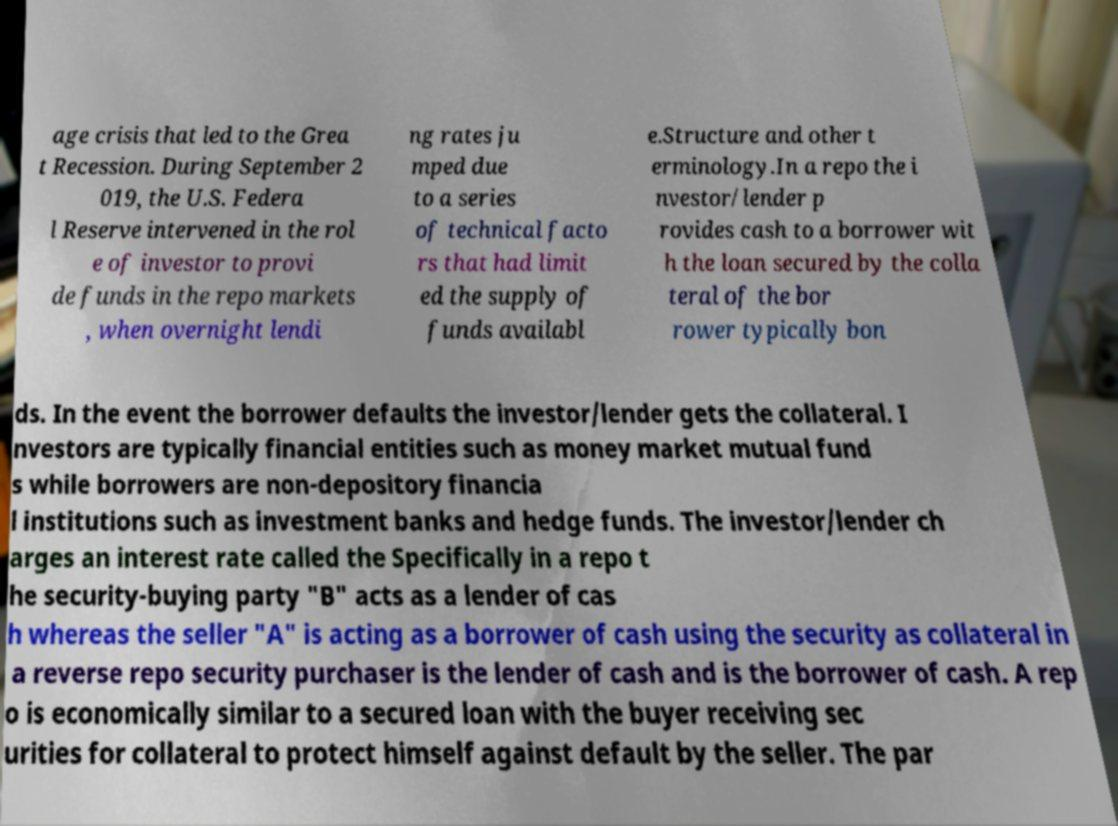Please identify and transcribe the text found in this image. age crisis that led to the Grea t Recession. During September 2 019, the U.S. Federa l Reserve intervened in the rol e of investor to provi de funds in the repo markets , when overnight lendi ng rates ju mped due to a series of technical facto rs that had limit ed the supply of funds availabl e.Structure and other t erminology.In a repo the i nvestor/lender p rovides cash to a borrower wit h the loan secured by the colla teral of the bor rower typically bon ds. In the event the borrower defaults the investor/lender gets the collateral. I nvestors are typically financial entities such as money market mutual fund s while borrowers are non-depository financia l institutions such as investment banks and hedge funds. The investor/lender ch arges an interest rate called the Specifically in a repo t he security-buying party "B" acts as a lender of cas h whereas the seller "A" is acting as a borrower of cash using the security as collateral in a reverse repo security purchaser is the lender of cash and is the borrower of cash. A rep o is economically similar to a secured loan with the buyer receiving sec urities for collateral to protect himself against default by the seller. The par 